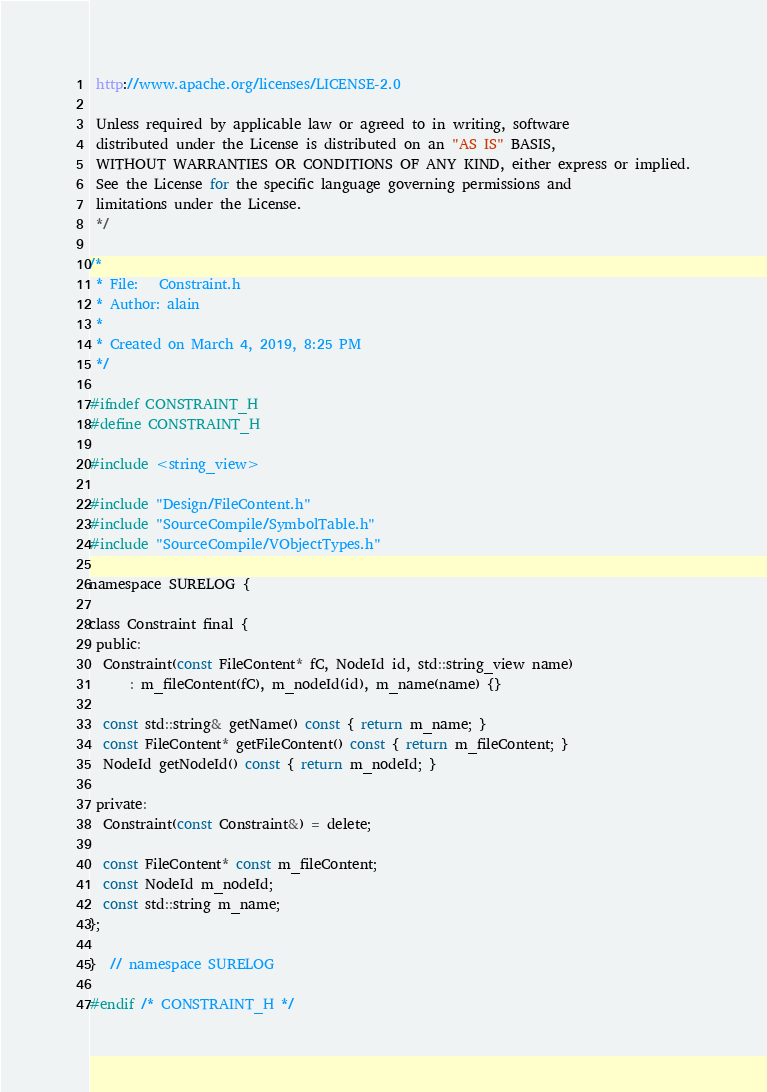<code> <loc_0><loc_0><loc_500><loc_500><_C_> http://www.apache.org/licenses/LICENSE-2.0

 Unless required by applicable law or agreed to in writing, software
 distributed under the License is distributed on an "AS IS" BASIS,
 WITHOUT WARRANTIES OR CONDITIONS OF ANY KIND, either express or implied.
 See the License for the specific language governing permissions and
 limitations under the License.
 */

/*
 * File:   Constraint.h
 * Author: alain
 *
 * Created on March 4, 2019, 8:25 PM
 */

#ifndef CONSTRAINT_H
#define CONSTRAINT_H

#include <string_view>

#include "Design/FileContent.h"
#include "SourceCompile/SymbolTable.h"
#include "SourceCompile/VObjectTypes.h"

namespace SURELOG {

class Constraint final {
 public:
  Constraint(const FileContent* fC, NodeId id, std::string_view name)
      : m_fileContent(fC), m_nodeId(id), m_name(name) {}

  const std::string& getName() const { return m_name; }
  const FileContent* getFileContent() const { return m_fileContent; }
  NodeId getNodeId() const { return m_nodeId; }

 private:
  Constraint(const Constraint&) = delete;

  const FileContent* const m_fileContent;
  const NodeId m_nodeId;
  const std::string m_name;
};

}  // namespace SURELOG

#endif /* CONSTRAINT_H */
</code> 